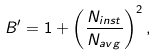<formula> <loc_0><loc_0><loc_500><loc_500>B ^ { \prime } = 1 + \left ( \frac { N _ { i n s t } } { N _ { a v g } } \right ) ^ { 2 } ,</formula> 